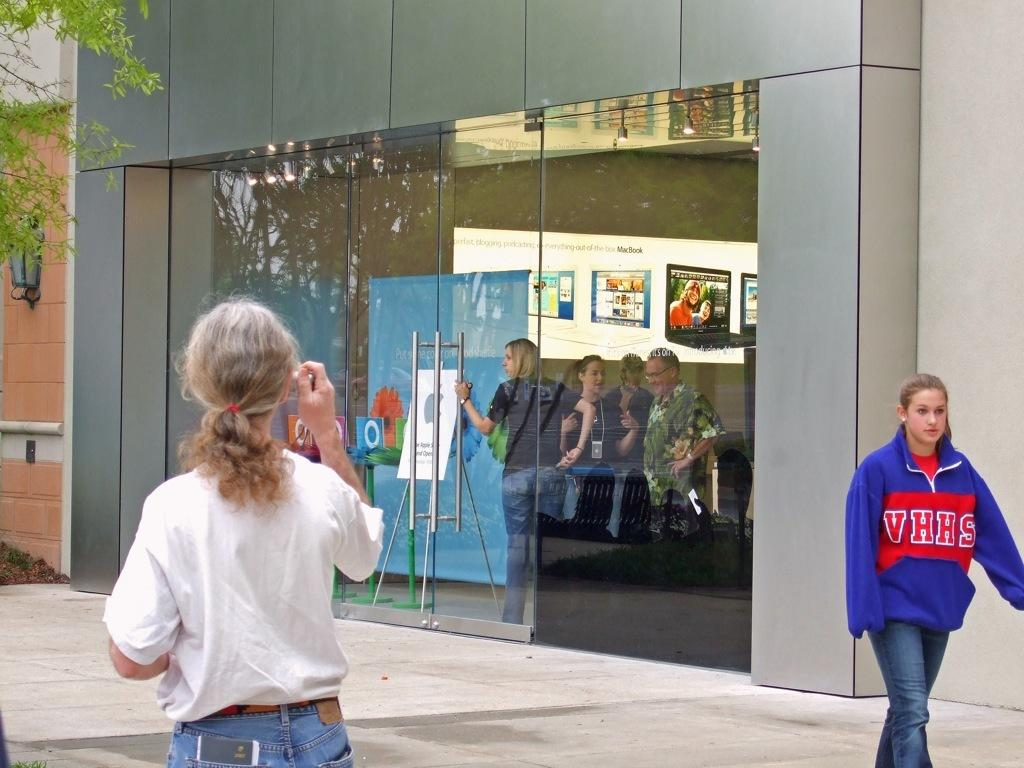<image>
Offer a succinct explanation of the picture presented. a person with a VHHS jacket on them 